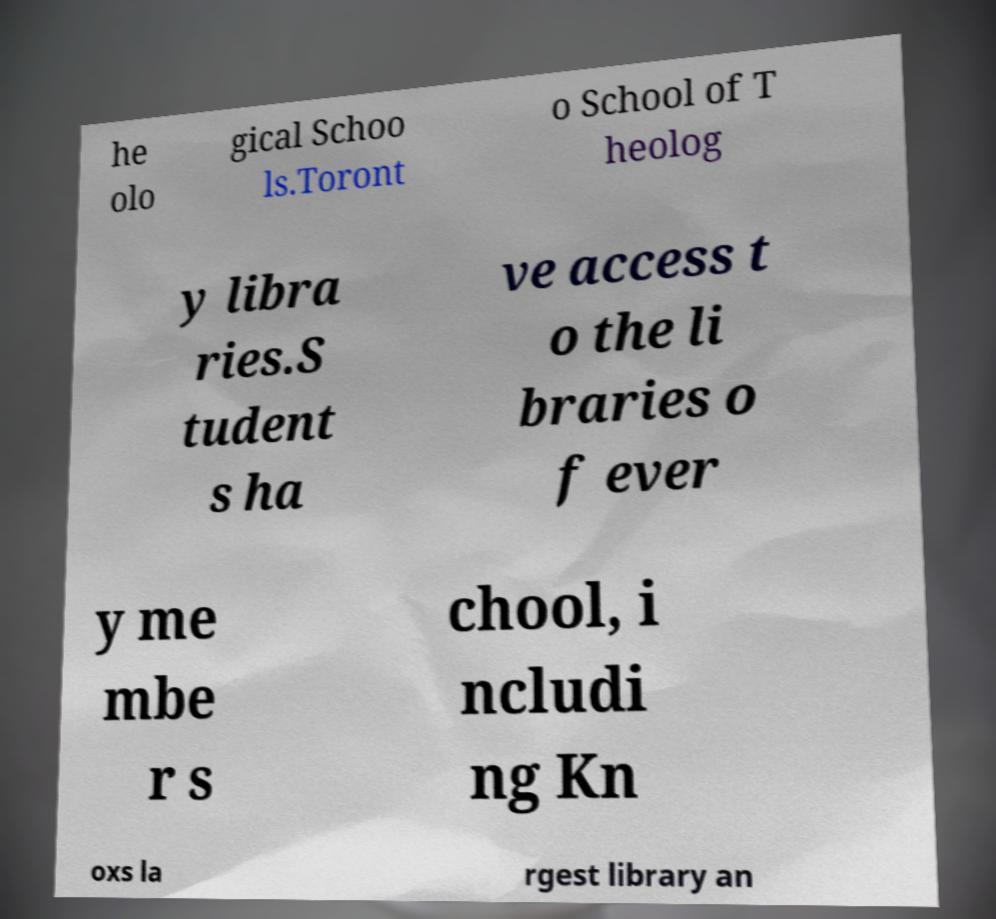For documentation purposes, I need the text within this image transcribed. Could you provide that? he olo gical Schoo ls.Toront o School of T heolog y libra ries.S tudent s ha ve access t o the li braries o f ever y me mbe r s chool, i ncludi ng Kn oxs la rgest library an 